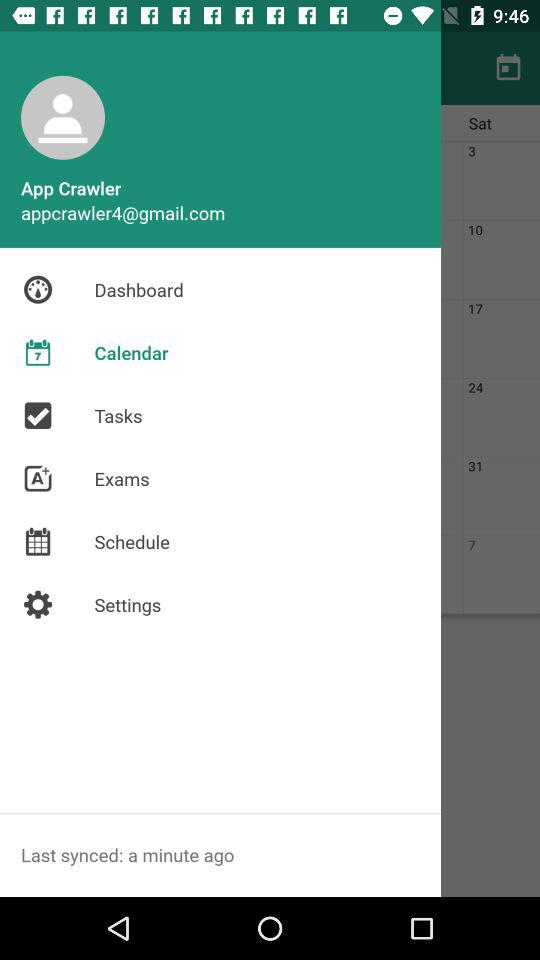Which item has been selected? The item that has been selected is "Calendar". 